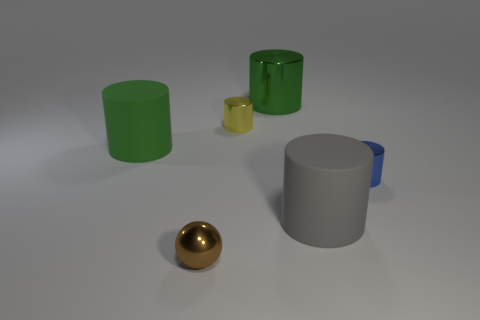Subtract all green cylinders. How many were subtracted if there are1green cylinders left? 1 Subtract all yellow cylinders. How many cylinders are left? 4 Subtract all tiny blue cylinders. How many cylinders are left? 4 Add 1 purple matte things. How many objects exist? 7 Subtract all brown cylinders. Subtract all blue blocks. How many cylinders are left? 5 Subtract all cylinders. How many objects are left? 1 Subtract 0 red blocks. How many objects are left? 6 Subtract all big gray cylinders. Subtract all large blue blocks. How many objects are left? 5 Add 6 big gray cylinders. How many big gray cylinders are left? 7 Add 3 tiny blue shiny spheres. How many tiny blue shiny spheres exist? 3 